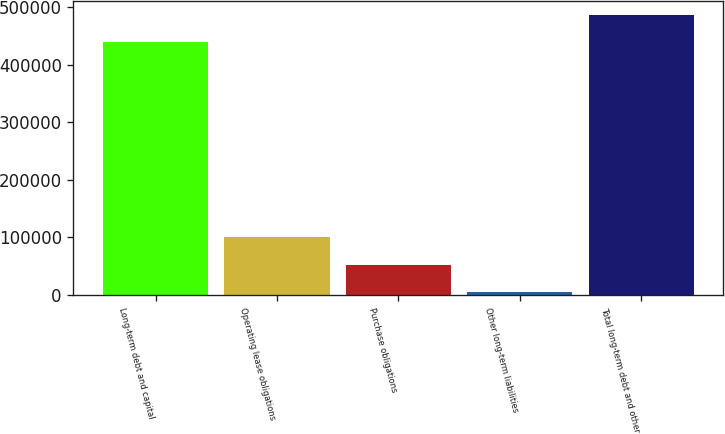Convert chart. <chart><loc_0><loc_0><loc_500><loc_500><bar_chart><fcel>Long-term debt and capital<fcel>Operating lease obligations<fcel>Purchase obligations<fcel>Other long-term liabilities<fcel>Total long-term debt and other<nl><fcel>438521<fcel>99539.8<fcel>51779.4<fcel>4019<fcel>486281<nl></chart> 